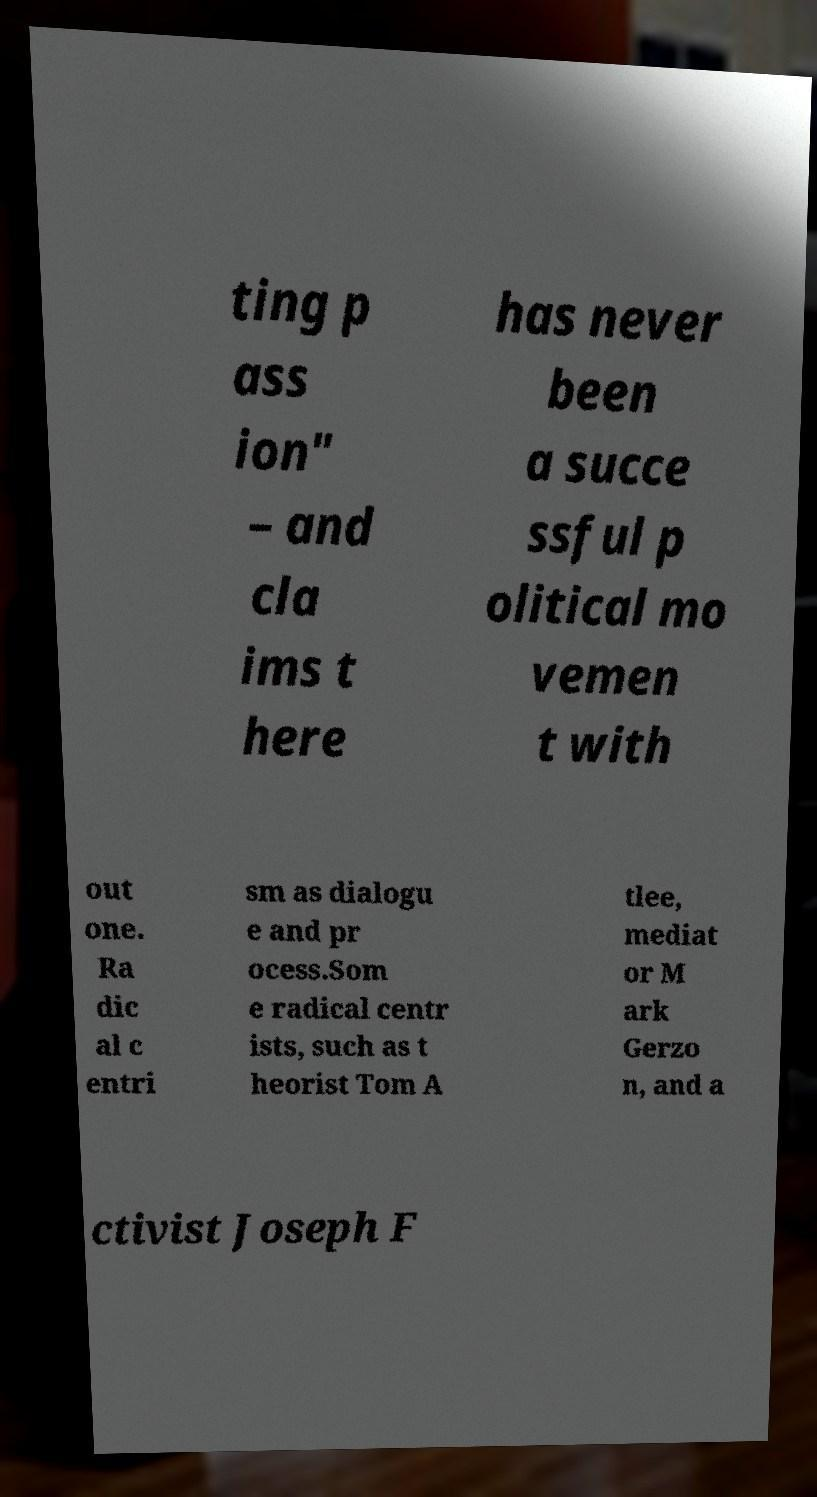Can you accurately transcribe the text from the provided image for me? ting p ass ion" – and cla ims t here has never been a succe ssful p olitical mo vemen t with out one. Ra dic al c entri sm as dialogu e and pr ocess.Som e radical centr ists, such as t heorist Tom A tlee, mediat or M ark Gerzo n, and a ctivist Joseph F 